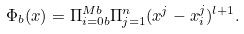<formula> <loc_0><loc_0><loc_500><loc_500>\Phi _ { b } ( x ) = \Pi _ { i = 0 b } ^ { M b } \Pi _ { j = 1 } ^ { n } ( x ^ { j } - x ^ { j } _ { i } ) ^ { l + 1 } .</formula> 